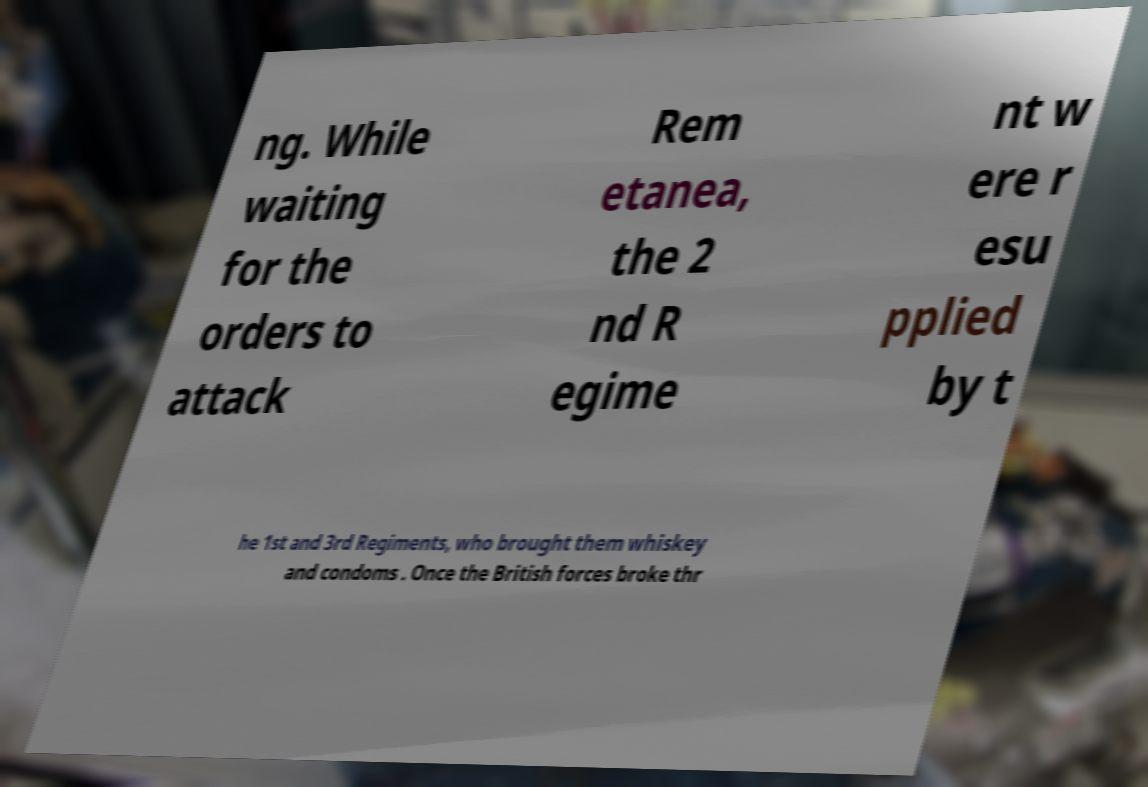There's text embedded in this image that I need extracted. Can you transcribe it verbatim? ng. While waiting for the orders to attack Rem etanea, the 2 nd R egime nt w ere r esu pplied by t he 1st and 3rd Regiments, who brought them whiskey and condoms . Once the British forces broke thr 